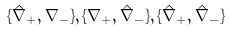Convert formula to latex. <formula><loc_0><loc_0><loc_500><loc_500>\{ \hat { \nabla } _ { + } , \nabla _ { - } \} , \{ \nabla _ { + } , \hat { \nabla } _ { - } \} , \{ \hat { \nabla } _ { + } , \hat { \nabla } _ { - } \}</formula> 